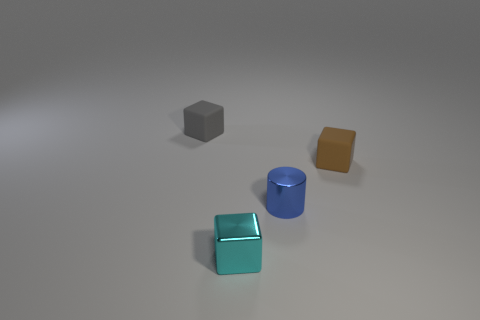Subtract all small metal blocks. How many blocks are left? 2 Subtract all brown cubes. How many cubes are left? 2 Subtract all blocks. How many objects are left? 1 Add 3 metal objects. How many objects exist? 7 Subtract all blue cubes. Subtract all red cylinders. How many cubes are left? 3 Subtract all red balls. How many red cylinders are left? 0 Subtract all big gray objects. Subtract all cyan shiny things. How many objects are left? 3 Add 4 tiny brown things. How many tiny brown things are left? 5 Add 1 tiny cyan objects. How many tiny cyan objects exist? 2 Subtract 0 blue blocks. How many objects are left? 4 